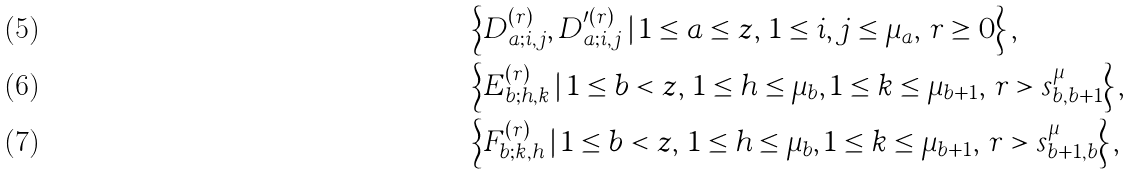<formula> <loc_0><loc_0><loc_500><loc_500>& \left \{ D _ { a ; i , j } ^ { ( r ) } , D _ { a ; i , j } ^ { \prime ( r ) } \, | \, { 1 \leq a \leq z , \, 1 \leq i , j \leq \mu _ { a } , \, r \geq 0 } \right \} , \\ & \left \{ E _ { b ; h , k } ^ { ( r ) } \, | \, { 1 \leq b < z , \, 1 \leq h \leq \mu _ { b } , 1 \leq k \leq \mu _ { b + 1 } , \, r > s _ { b , b + 1 } ^ { \mu } } \right \} , \\ & \left \{ F _ { b ; k , h } ^ { ( r ) } \, | \, { 1 \leq b < z , \, 1 \leq h \leq \mu _ { b } , 1 \leq k \leq \mu _ { b + 1 } , \, r > s _ { b + 1 , b } ^ { \mu } } \right \} ,</formula> 